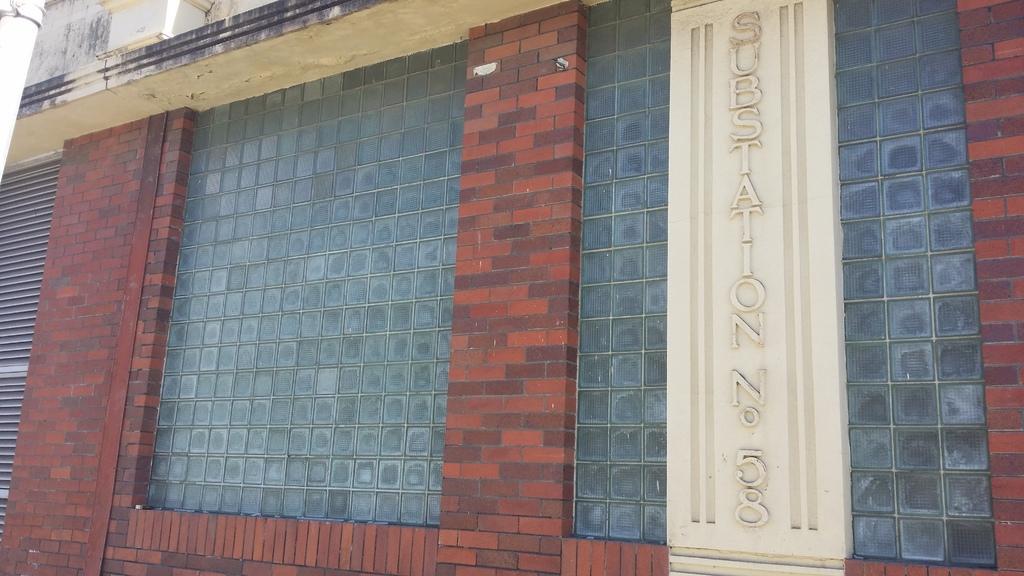In one or two sentences, can you explain what this image depicts? In this image we can see a building and there is some text on the wall. 